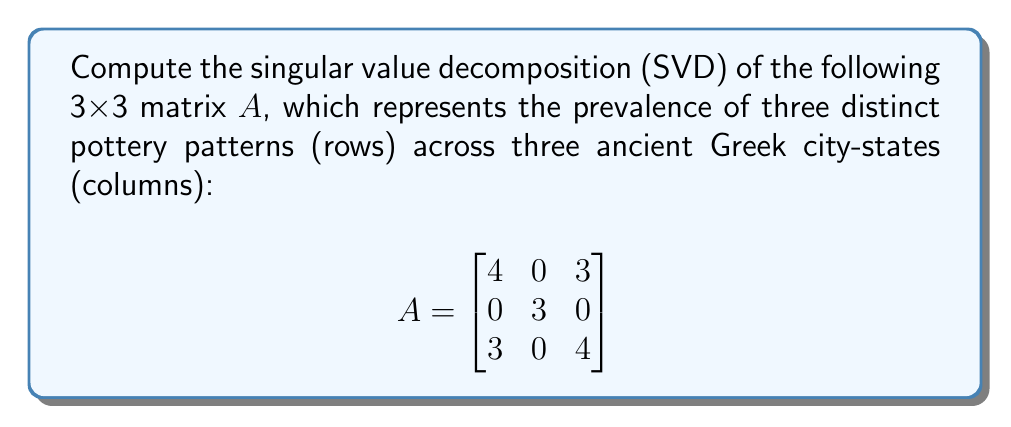Provide a solution to this math problem. To compute the SVD of matrix $A$, we need to find matrices $U$, $\Sigma$, and $V^T$ such that $A = U\Sigma V^T$.

Step 1: Compute $A^TA$ and $AA^T$
$$A^TA = \begin{bmatrix}
25 & 0 & 24\\
0 & 9 & 0\\
24 & 0 & 25
\end{bmatrix}$$

$$AA^T = \begin{bmatrix}
25 & 0 & 24\\
0 & 9 & 0\\
24 & 0 & 25
\end{bmatrix}$$

Step 2: Find eigenvalues of $A^TA$ (or $AA^T$)
Characteristic equation: $(\lambda - 9)(\lambda^2 - 50\lambda + 1) = 0$
Eigenvalues: $\lambda_1 = 49$, $\lambda_2 = 9$, $\lambda_3 = 1$

Step 3: Compute singular values
$\sigma_1 = \sqrt{49} = 7$, $\sigma_2 = 3$, $\sigma_3 = 1$

Step 4: Find eigenvectors of $A^TA$ to get columns of $V$
For $\lambda_1 = 49$: $v_1 = \frac{1}{\sqrt{2}}[1, 0, 1]^T$
For $\lambda_2 = 9$: $v_2 = [0, 1, 0]^T$
For $\lambda_3 = 1$: $v_3 = \frac{1}{\sqrt{2}}[-1, 0, 1]^T$

Step 5: Find eigenvectors of $AA^T$ to get columns of $U$
For $\lambda_1 = 49$: $u_1 = \frac{1}{\sqrt{2}}[1, 0, 1]^T$
For $\lambda_2 = 9$: $u_2 = [0, 1, 0]^T$
For $\lambda_3 = 1$: $u_3 = \frac{1}{\sqrt{2}}[-1, 0, 1]^T$

Step 6: Construct matrices $U$, $\Sigma$, and $V^T$

$$U = \begin{bmatrix}
\frac{1}{\sqrt{2}} & 0 & -\frac{1}{\sqrt{2}}\\
0 & 1 & 0\\
\frac{1}{\sqrt{2}} & 0 & \frac{1}{\sqrt{2}}
\end{bmatrix}$$

$$\Sigma = \begin{bmatrix}
7 & 0 & 0\\
0 & 3 & 0\\
0 & 0 & 1
\end{bmatrix}$$

$$V^T = \begin{bmatrix}
\frac{1}{\sqrt{2}} & 0 & \frac{1}{\sqrt{2}}\\
0 & 1 & 0\\
-\frac{1}{\sqrt{2}} & 0 & \frac{1}{\sqrt{2}}
\end{bmatrix}$$
Answer: $A = U\Sigma V^T$, where

$U = \begin{bmatrix}
\frac{1}{\sqrt{2}} & 0 & -\frac{1}{\sqrt{2}}\\
0 & 1 & 0\\
\frac{1}{\sqrt{2}} & 0 & \frac{1}{\sqrt{2}}
\end{bmatrix}$, 
$\Sigma = \begin{bmatrix}
7 & 0 & 0\\
0 & 3 & 0\\
0 & 0 & 1
\end{bmatrix}$, 
$V^T = \begin{bmatrix}
\frac{1}{\sqrt{2}} & 0 & \frac{1}{\sqrt{2}}\\
0 & 1 & 0\\
-\frac{1}{\sqrt{2}} & 0 & \frac{1}{\sqrt{2}}
\end{bmatrix}$ 